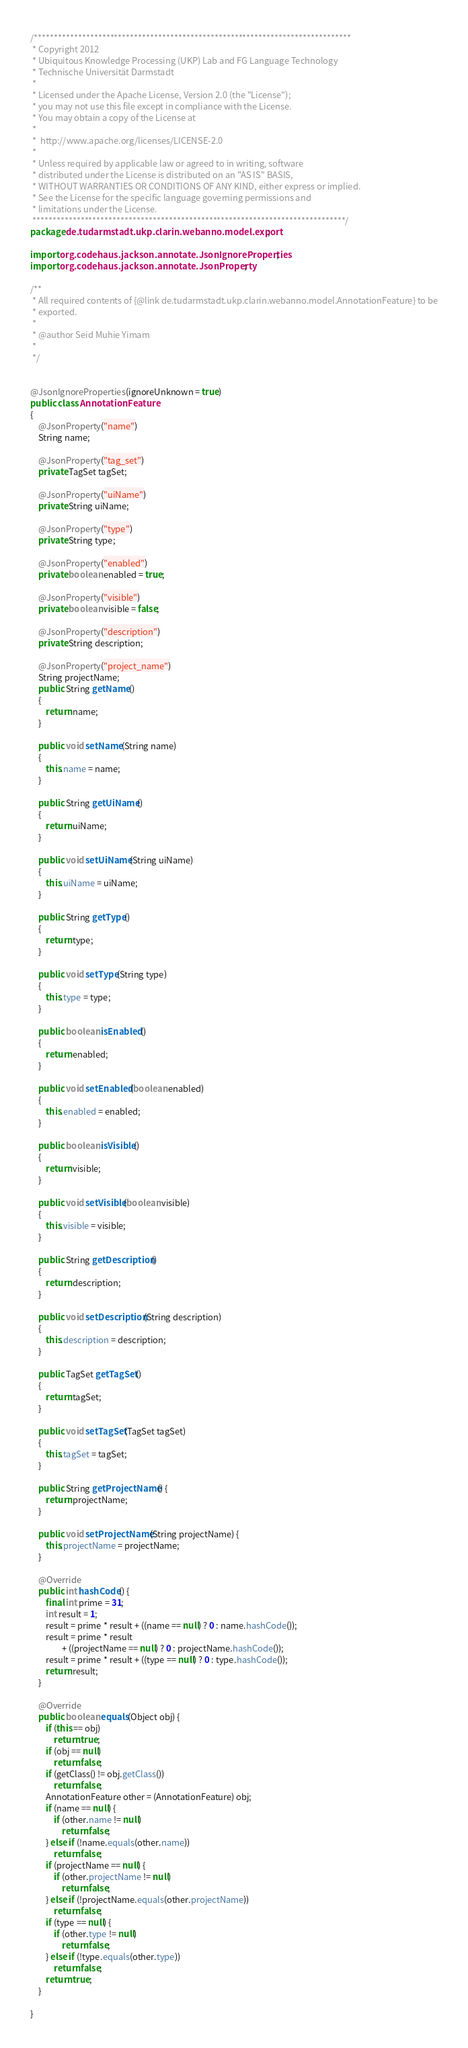<code> <loc_0><loc_0><loc_500><loc_500><_Java_>/*******************************************************************************
 * Copyright 2012
 * Ubiquitous Knowledge Processing (UKP) Lab and FG Language Technology
 * Technische Universität Darmstadt
 *
 * Licensed under the Apache License, Version 2.0 (the "License");
 * you may not use this file except in compliance with the License.
 * You may obtain a copy of the License at
 *
 *  http://www.apache.org/licenses/LICENSE-2.0
 *
 * Unless required by applicable law or agreed to in writing, software
 * distributed under the License is distributed on an "AS IS" BASIS,
 * WITHOUT WARRANTIES OR CONDITIONS OF ANY KIND, either express or implied.
 * See the License for the specific language governing permissions and
 * limitations under the License.
 ******************************************************************************/
package de.tudarmstadt.ukp.clarin.webanno.model.export;

import org.codehaus.jackson.annotate.JsonIgnoreProperties;
import org.codehaus.jackson.annotate.JsonProperty;

/**
 * All required contents of {@link de.tudarmstadt.ukp.clarin.webanno.model.AnnotationFeature} to be
 * exported.
 *
 * @author Seid Muhie Yimam
 *
 */


@JsonIgnoreProperties(ignoreUnknown = true)
public class AnnotationFeature
{
    @JsonProperty("name")
    String name;

    @JsonProperty("tag_set")
    private TagSet tagSet;

    @JsonProperty("uiName")
    private String uiName;

    @JsonProperty("type")
    private String type;

    @JsonProperty("enabled")
    private boolean enabled = true;

    @JsonProperty("visible")
    private boolean visible = false;

    @JsonProperty("description")
    private String description;

    @JsonProperty("project_name")
    String projectName;
    public String getName()
    {
        return name;
    }

    public void setName(String name)
    {
        this.name = name;
    }

    public String getUiName()
    {
        return uiName;
    }

    public void setUiName(String uiName)
    {
        this.uiName = uiName;
    }

    public String getType()
    {
        return type;
    }

    public void setType(String type)
    {
        this.type = type;
    }

    public boolean isEnabled()
    {
        return enabled;
    }

    public void setEnabled(boolean enabled)
    {
        this.enabled = enabled;
    }

    public boolean isVisible()
    {
        return visible;
    }

    public void setVisible(boolean visible)
    {
        this.visible = visible;
    }

    public String getDescription()
    {
        return description;
    }

    public void setDescription(String description)
    {
        this.description = description;
    }

    public TagSet getTagSet()
    {
        return tagSet;
    }

    public void setTagSet(TagSet tagSet)
    {
        this.tagSet = tagSet;
    }

	public String getProjectName() {
		return projectName;
	}

	public void setProjectName(String projectName) {
		this.projectName = projectName;
	}

	@Override
	public int hashCode() {
		final int prime = 31;
		int result = 1;
		result = prime * result + ((name == null) ? 0 : name.hashCode());
		result = prime * result
				+ ((projectName == null) ? 0 : projectName.hashCode());
		result = prime * result + ((type == null) ? 0 : type.hashCode());
		return result;
	}

	@Override
	public boolean equals(Object obj) {
		if (this == obj)
			return true;
		if (obj == null)
			return false;
		if (getClass() != obj.getClass())
			return false;
		AnnotationFeature other = (AnnotationFeature) obj;
		if (name == null) {
			if (other.name != null)
				return false;
		} else if (!name.equals(other.name))
			return false;
		if (projectName == null) {
			if (other.projectName != null)
				return false;
		} else if (!projectName.equals(other.projectName))
			return false;
		if (type == null) {
			if (other.type != null)
				return false;
		} else if (!type.equals(other.type))
			return false;
		return true;
	}

}
</code> 